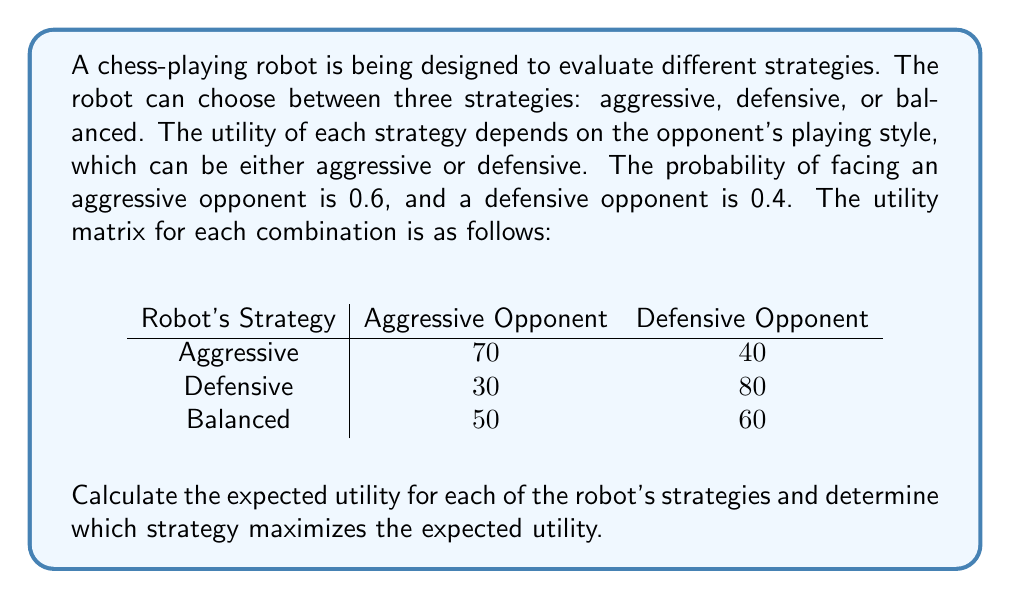Can you solve this math problem? To solve this problem, we need to calculate the expected utility for each of the robot's strategies using the given probabilities and utility values. The expected utility is the sum of the products of each outcome's probability and its corresponding utility.

Let's calculate the expected utility for each strategy:

1. Aggressive Strategy:
   $E(U_{aggressive}) = 0.6 \times 70 + 0.4 \times 40$
   $= 42 + 16 = 58$

2. Defensive Strategy:
   $E(U_{defensive}) = 0.6 \times 30 + 0.4 \times 80$
   $= 18 + 32 = 50$

3. Balanced Strategy:
   $E(U_{balanced}) = 0.6 \times 50 + 0.4 \times 60$
   $= 30 + 24 = 54$

Now, we compare the expected utilities:

$E(U_{aggressive}) = 58$
$E(U_{defensive}) = 50$
$E(U_{balanced}) = 54$

The strategy that maximizes the expected utility is the one with the highest value, which is the aggressive strategy with an expected utility of 58.
Answer: The aggressive strategy maximizes the expected utility with a value of 58. 